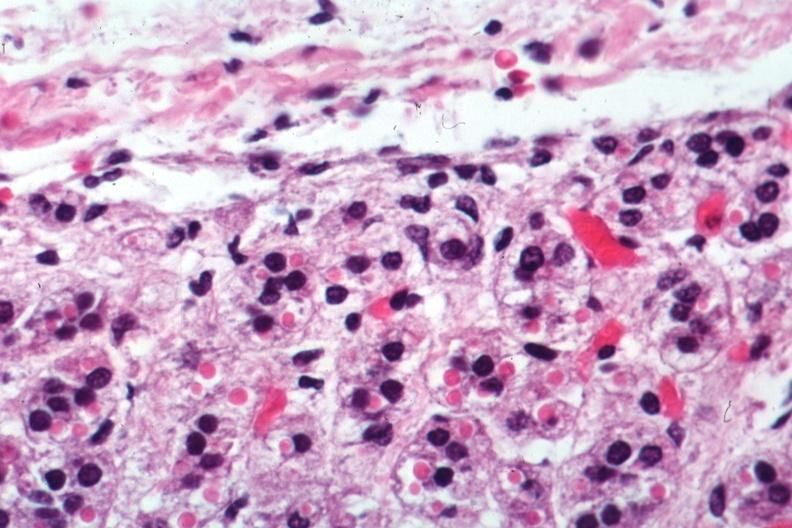does this image show excellent example?
Answer the question using a single word or phrase. Yes 